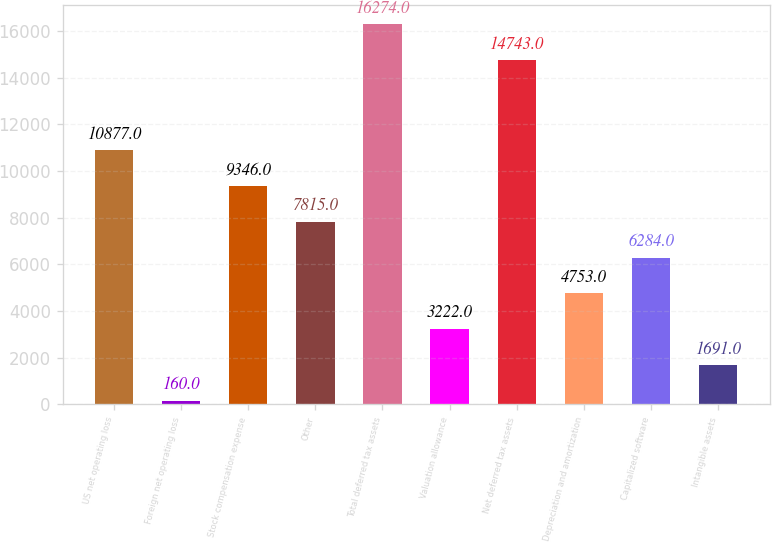Convert chart. <chart><loc_0><loc_0><loc_500><loc_500><bar_chart><fcel>US net operating loss<fcel>Foreign net operating loss<fcel>Stock compensation expense<fcel>Other<fcel>Total deferred tax assets<fcel>Valuation allowance<fcel>Net deferred tax assets<fcel>Depreciation and amortization<fcel>Capitalized software<fcel>Intangible assets<nl><fcel>10877<fcel>160<fcel>9346<fcel>7815<fcel>16274<fcel>3222<fcel>14743<fcel>4753<fcel>6284<fcel>1691<nl></chart> 